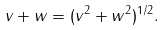Convert formula to latex. <formula><loc_0><loc_0><loc_500><loc_500>\| v + w \| = ( \| v \| ^ { 2 } + \| w \| ^ { 2 } ) ^ { 1 / 2 } .</formula> 